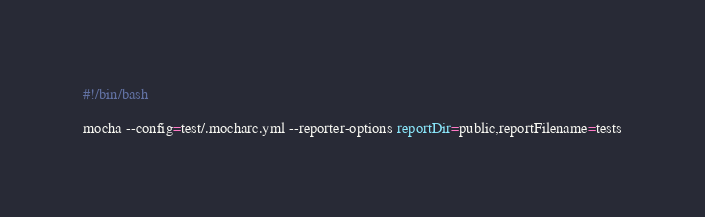<code> <loc_0><loc_0><loc_500><loc_500><_Bash_>#!/bin/bash

mocha --config=test/.mocharc.yml --reporter-options reportDir=public,reportFilename=tests
</code> 